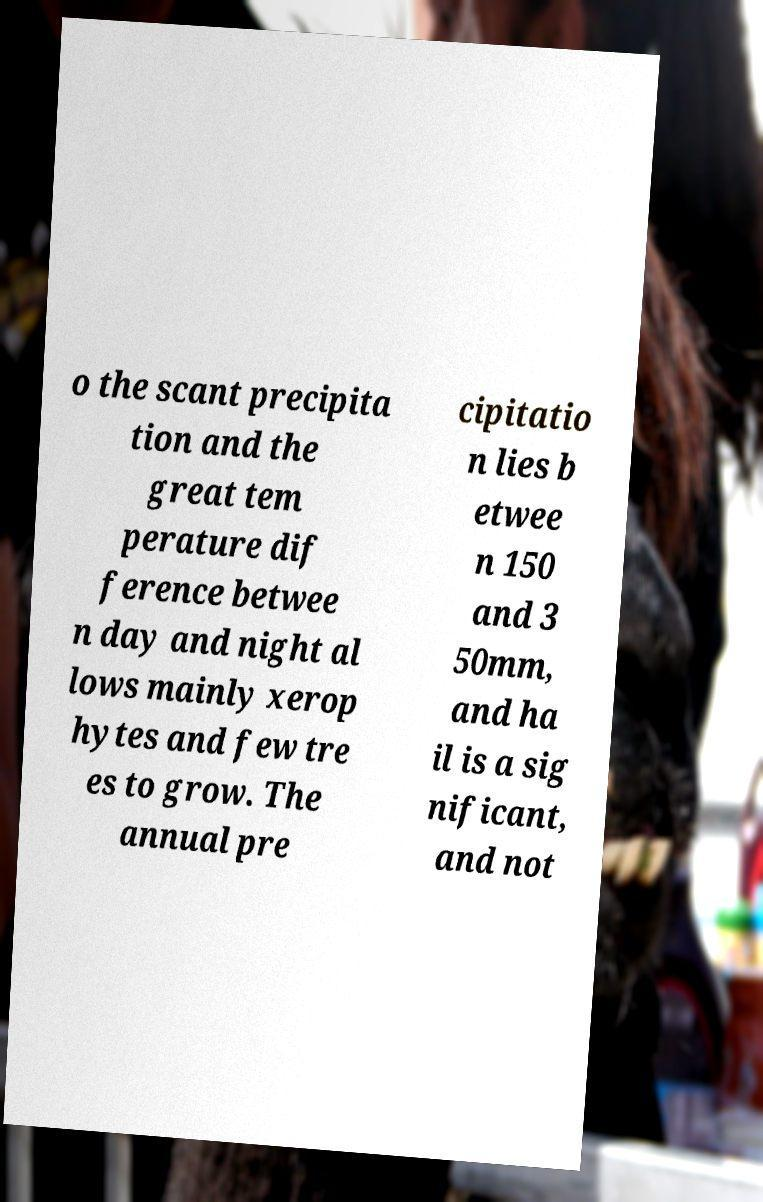For documentation purposes, I need the text within this image transcribed. Could you provide that? o the scant precipita tion and the great tem perature dif ference betwee n day and night al lows mainly xerop hytes and few tre es to grow. The annual pre cipitatio n lies b etwee n 150 and 3 50mm, and ha il is a sig nificant, and not 